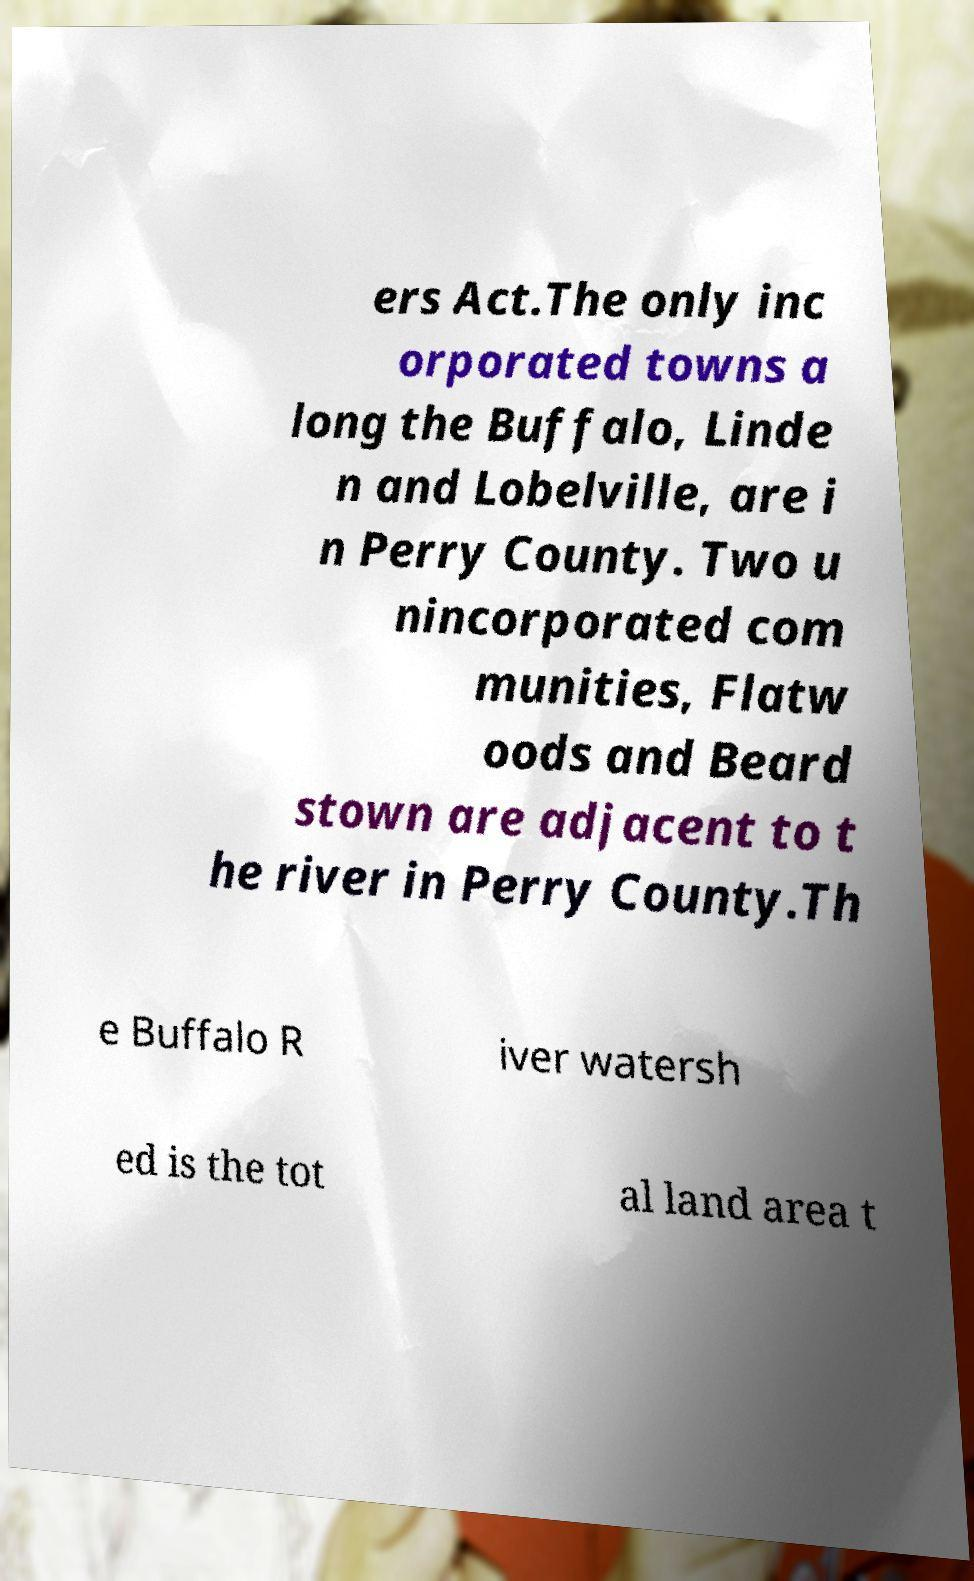Could you assist in decoding the text presented in this image and type it out clearly? ers Act.The only inc orporated towns a long the Buffalo, Linde n and Lobelville, are i n Perry County. Two u nincorporated com munities, Flatw oods and Beard stown are adjacent to t he river in Perry County.Th e Buffalo R iver watersh ed is the tot al land area t 